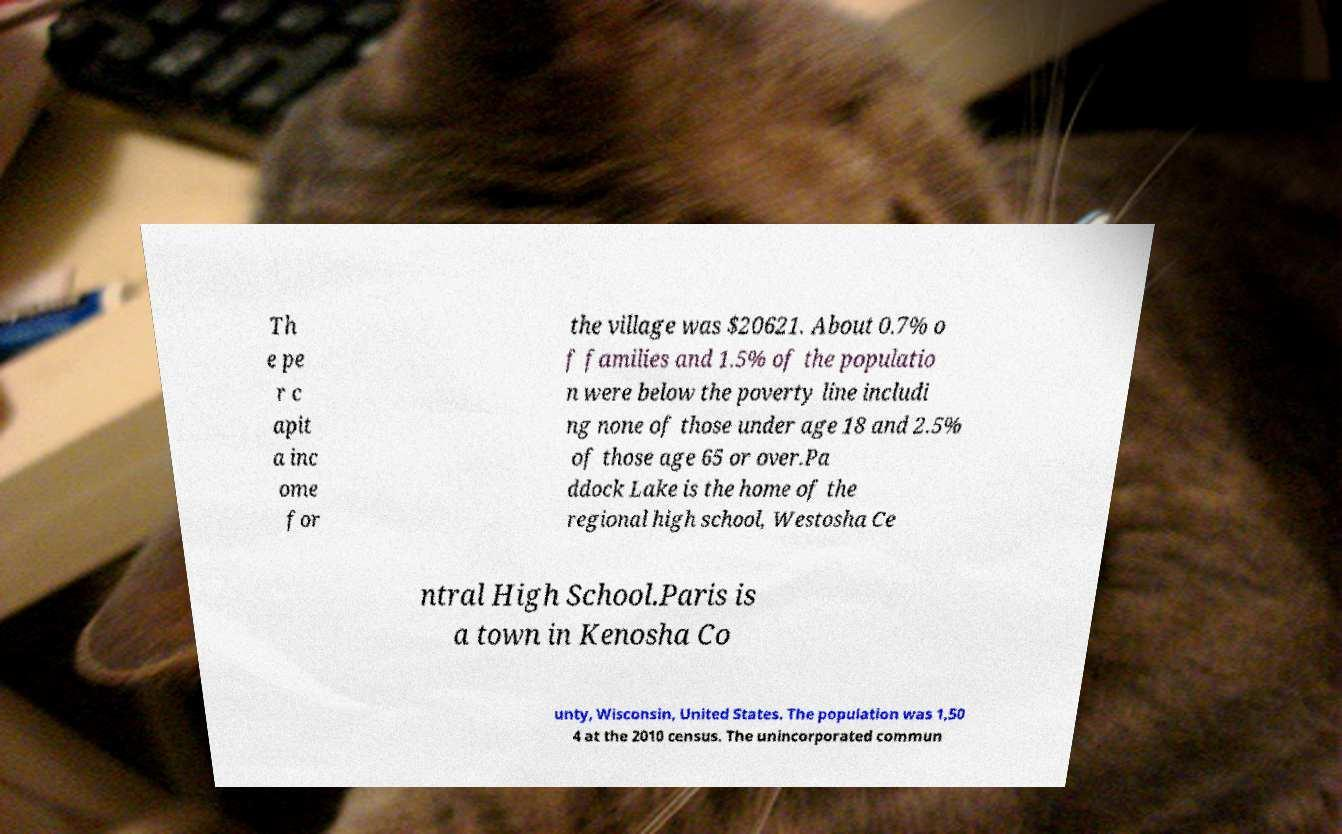Please read and relay the text visible in this image. What does it say? Th e pe r c apit a inc ome for the village was $20621. About 0.7% o f families and 1.5% of the populatio n were below the poverty line includi ng none of those under age 18 and 2.5% of those age 65 or over.Pa ddock Lake is the home of the regional high school, Westosha Ce ntral High School.Paris is a town in Kenosha Co unty, Wisconsin, United States. The population was 1,50 4 at the 2010 census. The unincorporated commun 